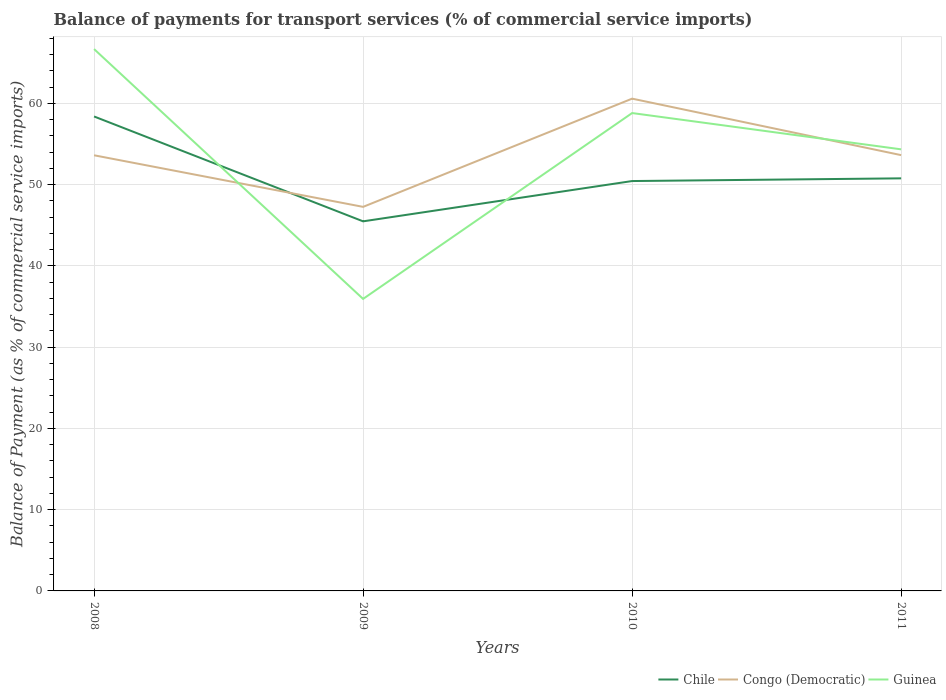Does the line corresponding to Chile intersect with the line corresponding to Congo (Democratic)?
Give a very brief answer. Yes. Across all years, what is the maximum balance of payments for transport services in Guinea?
Ensure brevity in your answer.  35.94. In which year was the balance of payments for transport services in Congo (Democratic) maximum?
Keep it short and to the point. 2009. What is the total balance of payments for transport services in Congo (Democratic) in the graph?
Your answer should be compact. -6.97. What is the difference between the highest and the second highest balance of payments for transport services in Chile?
Your response must be concise. 12.91. Is the balance of payments for transport services in Congo (Democratic) strictly greater than the balance of payments for transport services in Chile over the years?
Provide a succinct answer. No. How many years are there in the graph?
Make the answer very short. 4. Does the graph contain any zero values?
Provide a succinct answer. No. Where does the legend appear in the graph?
Offer a very short reply. Bottom right. How are the legend labels stacked?
Ensure brevity in your answer.  Horizontal. What is the title of the graph?
Your response must be concise. Balance of payments for transport services (% of commercial service imports). Does "Iceland" appear as one of the legend labels in the graph?
Your answer should be compact. No. What is the label or title of the Y-axis?
Provide a short and direct response. Balance of Payment (as % of commercial service imports). What is the Balance of Payment (as % of commercial service imports) of Chile in 2008?
Offer a very short reply. 58.4. What is the Balance of Payment (as % of commercial service imports) in Congo (Democratic) in 2008?
Give a very brief answer. 53.62. What is the Balance of Payment (as % of commercial service imports) of Guinea in 2008?
Keep it short and to the point. 66.7. What is the Balance of Payment (as % of commercial service imports) in Chile in 2009?
Offer a terse response. 45.49. What is the Balance of Payment (as % of commercial service imports) in Congo (Democratic) in 2009?
Provide a short and direct response. 47.27. What is the Balance of Payment (as % of commercial service imports) in Guinea in 2009?
Provide a short and direct response. 35.94. What is the Balance of Payment (as % of commercial service imports) in Chile in 2010?
Offer a terse response. 50.45. What is the Balance of Payment (as % of commercial service imports) of Congo (Democratic) in 2010?
Make the answer very short. 60.59. What is the Balance of Payment (as % of commercial service imports) in Guinea in 2010?
Make the answer very short. 58.82. What is the Balance of Payment (as % of commercial service imports) of Chile in 2011?
Keep it short and to the point. 50.78. What is the Balance of Payment (as % of commercial service imports) in Congo (Democratic) in 2011?
Keep it short and to the point. 53.64. What is the Balance of Payment (as % of commercial service imports) of Guinea in 2011?
Your answer should be compact. 54.35. Across all years, what is the maximum Balance of Payment (as % of commercial service imports) in Chile?
Your answer should be very brief. 58.4. Across all years, what is the maximum Balance of Payment (as % of commercial service imports) in Congo (Democratic)?
Offer a very short reply. 60.59. Across all years, what is the maximum Balance of Payment (as % of commercial service imports) of Guinea?
Ensure brevity in your answer.  66.7. Across all years, what is the minimum Balance of Payment (as % of commercial service imports) of Chile?
Offer a very short reply. 45.49. Across all years, what is the minimum Balance of Payment (as % of commercial service imports) of Congo (Democratic)?
Your answer should be compact. 47.27. Across all years, what is the minimum Balance of Payment (as % of commercial service imports) of Guinea?
Provide a succinct answer. 35.94. What is the total Balance of Payment (as % of commercial service imports) in Chile in the graph?
Your answer should be very brief. 205.13. What is the total Balance of Payment (as % of commercial service imports) of Congo (Democratic) in the graph?
Offer a very short reply. 215.13. What is the total Balance of Payment (as % of commercial service imports) in Guinea in the graph?
Make the answer very short. 215.82. What is the difference between the Balance of Payment (as % of commercial service imports) of Chile in 2008 and that in 2009?
Offer a very short reply. 12.91. What is the difference between the Balance of Payment (as % of commercial service imports) of Congo (Democratic) in 2008 and that in 2009?
Keep it short and to the point. 6.35. What is the difference between the Balance of Payment (as % of commercial service imports) of Guinea in 2008 and that in 2009?
Keep it short and to the point. 30.75. What is the difference between the Balance of Payment (as % of commercial service imports) of Chile in 2008 and that in 2010?
Ensure brevity in your answer.  7.95. What is the difference between the Balance of Payment (as % of commercial service imports) of Congo (Democratic) in 2008 and that in 2010?
Provide a short and direct response. -6.97. What is the difference between the Balance of Payment (as % of commercial service imports) of Guinea in 2008 and that in 2010?
Your answer should be compact. 7.88. What is the difference between the Balance of Payment (as % of commercial service imports) of Chile in 2008 and that in 2011?
Keep it short and to the point. 7.61. What is the difference between the Balance of Payment (as % of commercial service imports) of Congo (Democratic) in 2008 and that in 2011?
Offer a terse response. -0.02. What is the difference between the Balance of Payment (as % of commercial service imports) of Guinea in 2008 and that in 2011?
Offer a terse response. 12.34. What is the difference between the Balance of Payment (as % of commercial service imports) of Chile in 2009 and that in 2010?
Provide a short and direct response. -4.96. What is the difference between the Balance of Payment (as % of commercial service imports) of Congo (Democratic) in 2009 and that in 2010?
Offer a very short reply. -13.32. What is the difference between the Balance of Payment (as % of commercial service imports) in Guinea in 2009 and that in 2010?
Your answer should be very brief. -22.88. What is the difference between the Balance of Payment (as % of commercial service imports) in Chile in 2009 and that in 2011?
Your answer should be compact. -5.29. What is the difference between the Balance of Payment (as % of commercial service imports) in Congo (Democratic) in 2009 and that in 2011?
Ensure brevity in your answer.  -6.37. What is the difference between the Balance of Payment (as % of commercial service imports) of Guinea in 2009 and that in 2011?
Give a very brief answer. -18.41. What is the difference between the Balance of Payment (as % of commercial service imports) of Chile in 2010 and that in 2011?
Offer a very short reply. -0.33. What is the difference between the Balance of Payment (as % of commercial service imports) in Congo (Democratic) in 2010 and that in 2011?
Offer a terse response. 6.95. What is the difference between the Balance of Payment (as % of commercial service imports) of Guinea in 2010 and that in 2011?
Your answer should be compact. 4.47. What is the difference between the Balance of Payment (as % of commercial service imports) of Chile in 2008 and the Balance of Payment (as % of commercial service imports) of Congo (Democratic) in 2009?
Provide a succinct answer. 11.13. What is the difference between the Balance of Payment (as % of commercial service imports) in Chile in 2008 and the Balance of Payment (as % of commercial service imports) in Guinea in 2009?
Your answer should be very brief. 22.45. What is the difference between the Balance of Payment (as % of commercial service imports) of Congo (Democratic) in 2008 and the Balance of Payment (as % of commercial service imports) of Guinea in 2009?
Ensure brevity in your answer.  17.68. What is the difference between the Balance of Payment (as % of commercial service imports) of Chile in 2008 and the Balance of Payment (as % of commercial service imports) of Congo (Democratic) in 2010?
Your answer should be compact. -2.2. What is the difference between the Balance of Payment (as % of commercial service imports) in Chile in 2008 and the Balance of Payment (as % of commercial service imports) in Guinea in 2010?
Make the answer very short. -0.42. What is the difference between the Balance of Payment (as % of commercial service imports) in Congo (Democratic) in 2008 and the Balance of Payment (as % of commercial service imports) in Guinea in 2010?
Your answer should be compact. -5.2. What is the difference between the Balance of Payment (as % of commercial service imports) of Chile in 2008 and the Balance of Payment (as % of commercial service imports) of Congo (Democratic) in 2011?
Ensure brevity in your answer.  4.76. What is the difference between the Balance of Payment (as % of commercial service imports) in Chile in 2008 and the Balance of Payment (as % of commercial service imports) in Guinea in 2011?
Offer a very short reply. 4.04. What is the difference between the Balance of Payment (as % of commercial service imports) of Congo (Democratic) in 2008 and the Balance of Payment (as % of commercial service imports) of Guinea in 2011?
Give a very brief answer. -0.73. What is the difference between the Balance of Payment (as % of commercial service imports) in Chile in 2009 and the Balance of Payment (as % of commercial service imports) in Congo (Democratic) in 2010?
Provide a short and direct response. -15.1. What is the difference between the Balance of Payment (as % of commercial service imports) in Chile in 2009 and the Balance of Payment (as % of commercial service imports) in Guinea in 2010?
Give a very brief answer. -13.33. What is the difference between the Balance of Payment (as % of commercial service imports) of Congo (Democratic) in 2009 and the Balance of Payment (as % of commercial service imports) of Guinea in 2010?
Your answer should be compact. -11.55. What is the difference between the Balance of Payment (as % of commercial service imports) in Chile in 2009 and the Balance of Payment (as % of commercial service imports) in Congo (Democratic) in 2011?
Provide a succinct answer. -8.15. What is the difference between the Balance of Payment (as % of commercial service imports) of Chile in 2009 and the Balance of Payment (as % of commercial service imports) of Guinea in 2011?
Give a very brief answer. -8.86. What is the difference between the Balance of Payment (as % of commercial service imports) of Congo (Democratic) in 2009 and the Balance of Payment (as % of commercial service imports) of Guinea in 2011?
Ensure brevity in your answer.  -7.08. What is the difference between the Balance of Payment (as % of commercial service imports) in Chile in 2010 and the Balance of Payment (as % of commercial service imports) in Congo (Democratic) in 2011?
Make the answer very short. -3.19. What is the difference between the Balance of Payment (as % of commercial service imports) of Chile in 2010 and the Balance of Payment (as % of commercial service imports) of Guinea in 2011?
Give a very brief answer. -3.9. What is the difference between the Balance of Payment (as % of commercial service imports) in Congo (Democratic) in 2010 and the Balance of Payment (as % of commercial service imports) in Guinea in 2011?
Make the answer very short. 6.24. What is the average Balance of Payment (as % of commercial service imports) of Chile per year?
Offer a very short reply. 51.28. What is the average Balance of Payment (as % of commercial service imports) in Congo (Democratic) per year?
Ensure brevity in your answer.  53.78. What is the average Balance of Payment (as % of commercial service imports) of Guinea per year?
Provide a succinct answer. 53.95. In the year 2008, what is the difference between the Balance of Payment (as % of commercial service imports) of Chile and Balance of Payment (as % of commercial service imports) of Congo (Democratic)?
Ensure brevity in your answer.  4.78. In the year 2008, what is the difference between the Balance of Payment (as % of commercial service imports) in Chile and Balance of Payment (as % of commercial service imports) in Guinea?
Make the answer very short. -8.3. In the year 2008, what is the difference between the Balance of Payment (as % of commercial service imports) in Congo (Democratic) and Balance of Payment (as % of commercial service imports) in Guinea?
Provide a succinct answer. -13.07. In the year 2009, what is the difference between the Balance of Payment (as % of commercial service imports) of Chile and Balance of Payment (as % of commercial service imports) of Congo (Democratic)?
Your answer should be compact. -1.78. In the year 2009, what is the difference between the Balance of Payment (as % of commercial service imports) in Chile and Balance of Payment (as % of commercial service imports) in Guinea?
Your answer should be compact. 9.55. In the year 2009, what is the difference between the Balance of Payment (as % of commercial service imports) of Congo (Democratic) and Balance of Payment (as % of commercial service imports) of Guinea?
Offer a very short reply. 11.33. In the year 2010, what is the difference between the Balance of Payment (as % of commercial service imports) of Chile and Balance of Payment (as % of commercial service imports) of Congo (Democratic)?
Provide a succinct answer. -10.14. In the year 2010, what is the difference between the Balance of Payment (as % of commercial service imports) in Chile and Balance of Payment (as % of commercial service imports) in Guinea?
Provide a succinct answer. -8.37. In the year 2010, what is the difference between the Balance of Payment (as % of commercial service imports) in Congo (Democratic) and Balance of Payment (as % of commercial service imports) in Guinea?
Give a very brief answer. 1.77. In the year 2011, what is the difference between the Balance of Payment (as % of commercial service imports) in Chile and Balance of Payment (as % of commercial service imports) in Congo (Democratic)?
Your answer should be compact. -2.86. In the year 2011, what is the difference between the Balance of Payment (as % of commercial service imports) of Chile and Balance of Payment (as % of commercial service imports) of Guinea?
Your answer should be compact. -3.57. In the year 2011, what is the difference between the Balance of Payment (as % of commercial service imports) of Congo (Democratic) and Balance of Payment (as % of commercial service imports) of Guinea?
Keep it short and to the point. -0.71. What is the ratio of the Balance of Payment (as % of commercial service imports) of Chile in 2008 to that in 2009?
Provide a short and direct response. 1.28. What is the ratio of the Balance of Payment (as % of commercial service imports) of Congo (Democratic) in 2008 to that in 2009?
Your response must be concise. 1.13. What is the ratio of the Balance of Payment (as % of commercial service imports) in Guinea in 2008 to that in 2009?
Keep it short and to the point. 1.86. What is the ratio of the Balance of Payment (as % of commercial service imports) in Chile in 2008 to that in 2010?
Offer a very short reply. 1.16. What is the ratio of the Balance of Payment (as % of commercial service imports) in Congo (Democratic) in 2008 to that in 2010?
Give a very brief answer. 0.89. What is the ratio of the Balance of Payment (as % of commercial service imports) in Guinea in 2008 to that in 2010?
Make the answer very short. 1.13. What is the ratio of the Balance of Payment (as % of commercial service imports) of Chile in 2008 to that in 2011?
Provide a succinct answer. 1.15. What is the ratio of the Balance of Payment (as % of commercial service imports) in Congo (Democratic) in 2008 to that in 2011?
Your response must be concise. 1. What is the ratio of the Balance of Payment (as % of commercial service imports) of Guinea in 2008 to that in 2011?
Keep it short and to the point. 1.23. What is the ratio of the Balance of Payment (as % of commercial service imports) in Chile in 2009 to that in 2010?
Offer a terse response. 0.9. What is the ratio of the Balance of Payment (as % of commercial service imports) of Congo (Democratic) in 2009 to that in 2010?
Your answer should be very brief. 0.78. What is the ratio of the Balance of Payment (as % of commercial service imports) in Guinea in 2009 to that in 2010?
Your answer should be very brief. 0.61. What is the ratio of the Balance of Payment (as % of commercial service imports) of Chile in 2009 to that in 2011?
Provide a short and direct response. 0.9. What is the ratio of the Balance of Payment (as % of commercial service imports) of Congo (Democratic) in 2009 to that in 2011?
Ensure brevity in your answer.  0.88. What is the ratio of the Balance of Payment (as % of commercial service imports) in Guinea in 2009 to that in 2011?
Make the answer very short. 0.66. What is the ratio of the Balance of Payment (as % of commercial service imports) of Chile in 2010 to that in 2011?
Keep it short and to the point. 0.99. What is the ratio of the Balance of Payment (as % of commercial service imports) in Congo (Democratic) in 2010 to that in 2011?
Offer a very short reply. 1.13. What is the ratio of the Balance of Payment (as % of commercial service imports) in Guinea in 2010 to that in 2011?
Ensure brevity in your answer.  1.08. What is the difference between the highest and the second highest Balance of Payment (as % of commercial service imports) of Chile?
Give a very brief answer. 7.61. What is the difference between the highest and the second highest Balance of Payment (as % of commercial service imports) of Congo (Democratic)?
Keep it short and to the point. 6.95. What is the difference between the highest and the second highest Balance of Payment (as % of commercial service imports) in Guinea?
Provide a succinct answer. 7.88. What is the difference between the highest and the lowest Balance of Payment (as % of commercial service imports) in Chile?
Keep it short and to the point. 12.91. What is the difference between the highest and the lowest Balance of Payment (as % of commercial service imports) in Congo (Democratic)?
Your response must be concise. 13.32. What is the difference between the highest and the lowest Balance of Payment (as % of commercial service imports) of Guinea?
Your response must be concise. 30.75. 